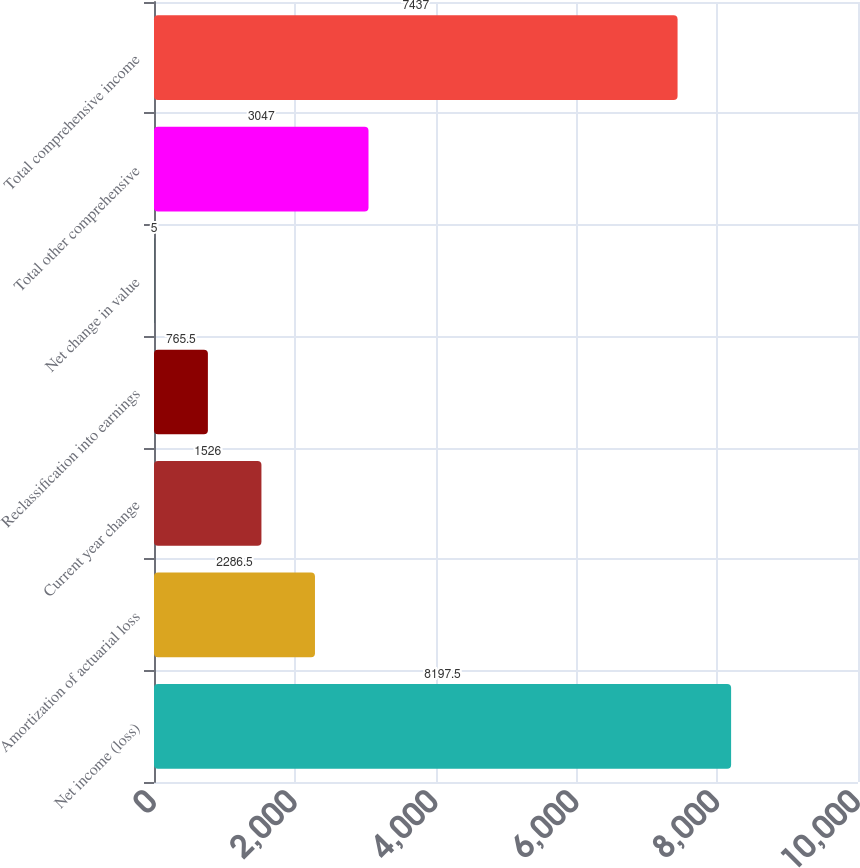Convert chart. <chart><loc_0><loc_0><loc_500><loc_500><bar_chart><fcel>Net income (loss)<fcel>Amortization of actuarial loss<fcel>Current year change<fcel>Reclassification into earnings<fcel>Net change in value<fcel>Total other comprehensive<fcel>Total comprehensive income<nl><fcel>8197.5<fcel>2286.5<fcel>1526<fcel>765.5<fcel>5<fcel>3047<fcel>7437<nl></chart> 